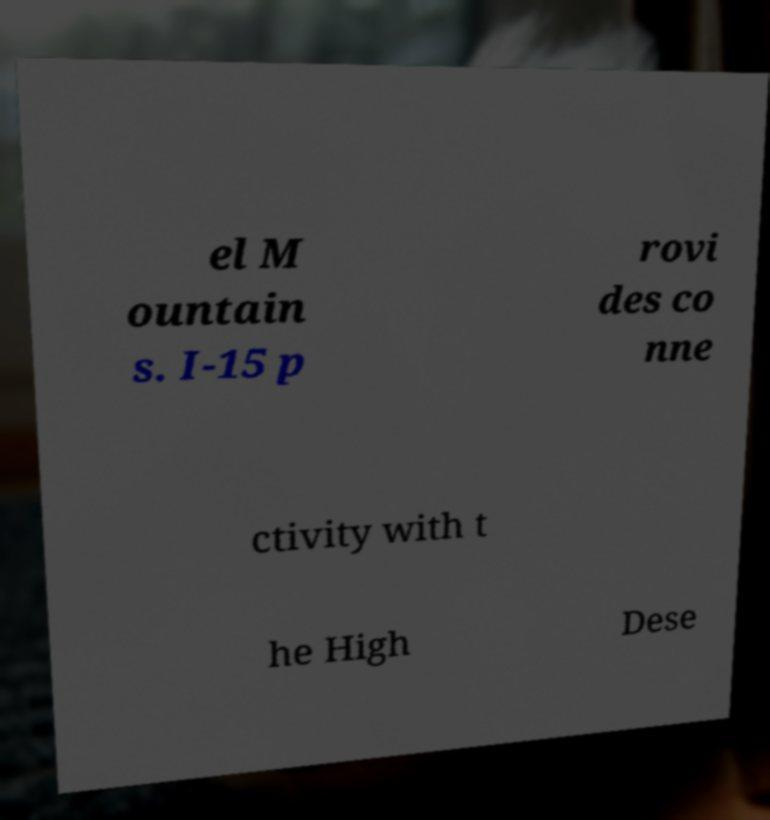What messages or text are displayed in this image? I need them in a readable, typed format. el M ountain s. I-15 p rovi des co nne ctivity with t he High Dese 